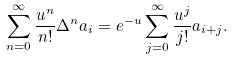<formula> <loc_0><loc_0><loc_500><loc_500>\sum _ { n = 0 } ^ { \infty } { \frac { u ^ { n } } { n ! } } \Delta ^ { n } a _ { i } = e ^ { - u } \sum _ { j = 0 } ^ { \infty } { \frac { u ^ { j } } { j ! } } a _ { i + j } .</formula> 